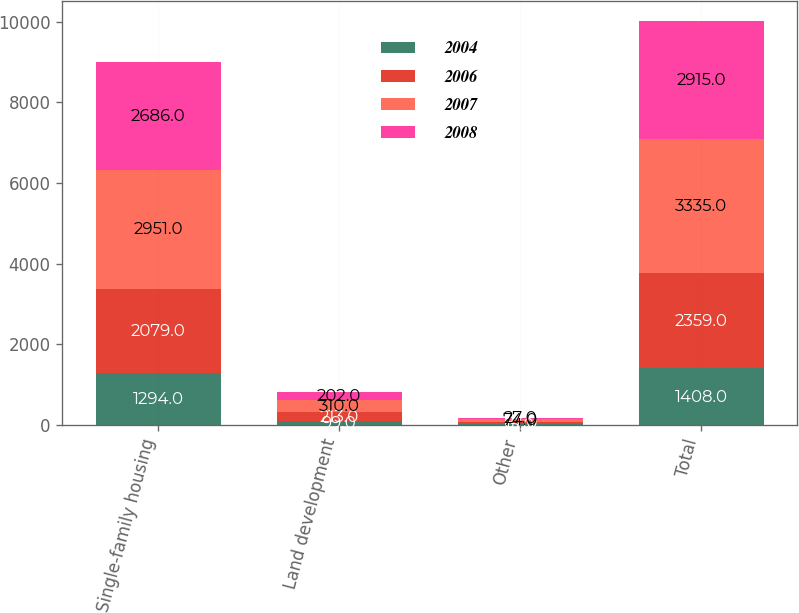<chart> <loc_0><loc_0><loc_500><loc_500><stacked_bar_chart><ecel><fcel>Single-family housing<fcel>Land development<fcel>Other<fcel>Total<nl><fcel>2004<fcel>1294<fcel>99<fcel>15<fcel>1408<nl><fcel>2006<fcel>2079<fcel>213<fcel>67<fcel>2359<nl><fcel>2007<fcel>2951<fcel>310<fcel>74<fcel>3335<nl><fcel>2008<fcel>2686<fcel>202<fcel>27<fcel>2915<nl></chart> 